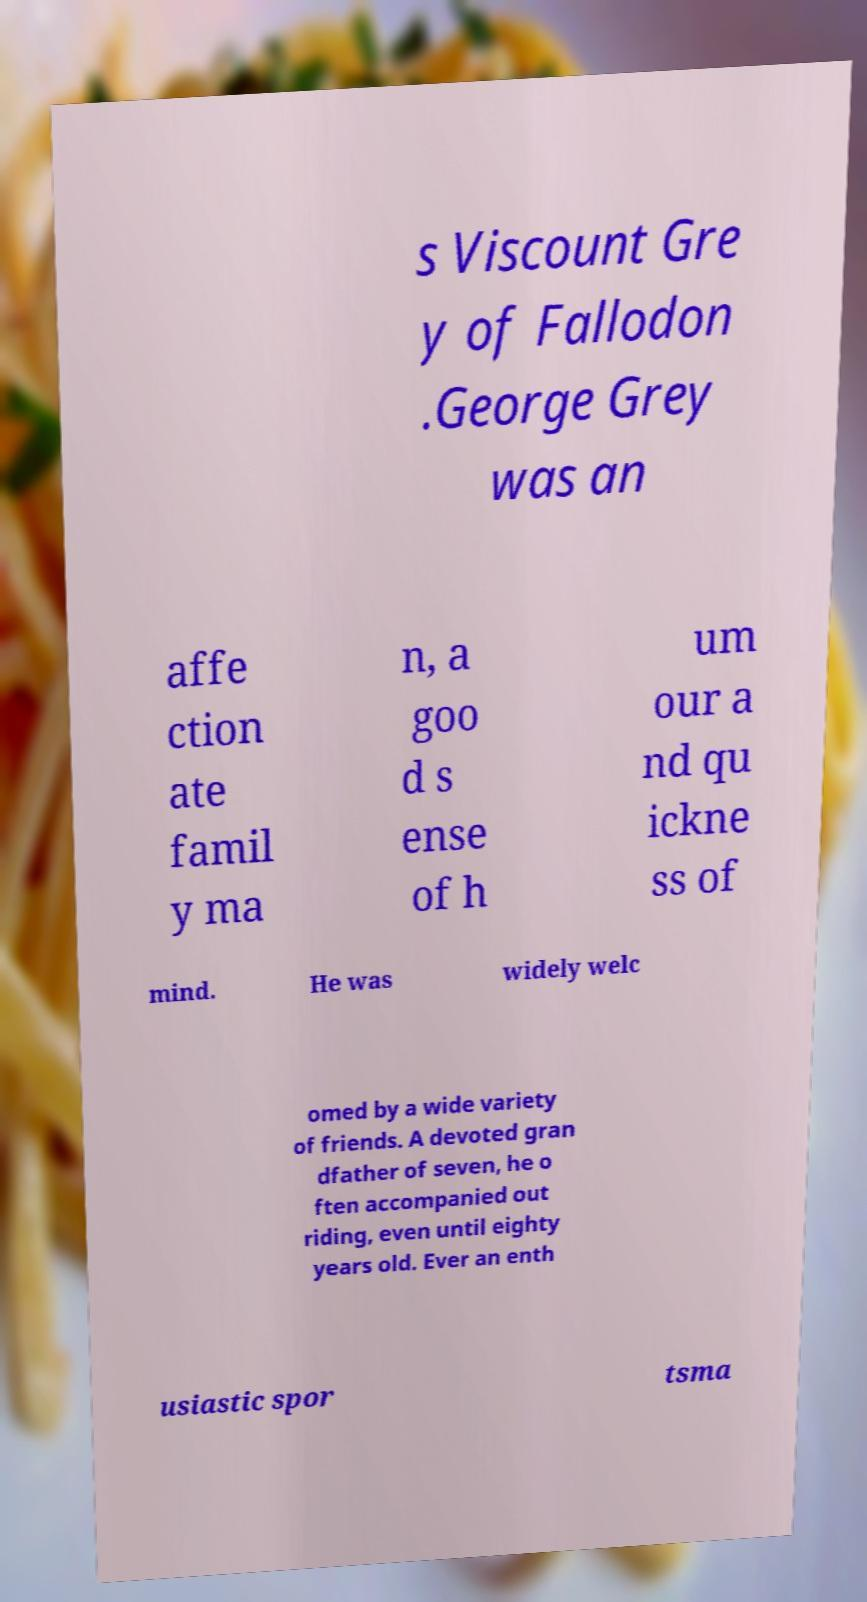Please read and relay the text visible in this image. What does it say? s Viscount Gre y of Fallodon .George Grey was an affe ction ate famil y ma n, a goo d s ense of h um our a nd qu ickne ss of mind. He was widely welc omed by a wide variety of friends. A devoted gran dfather of seven, he o ften accompanied out riding, even until eighty years old. Ever an enth usiastic spor tsma 